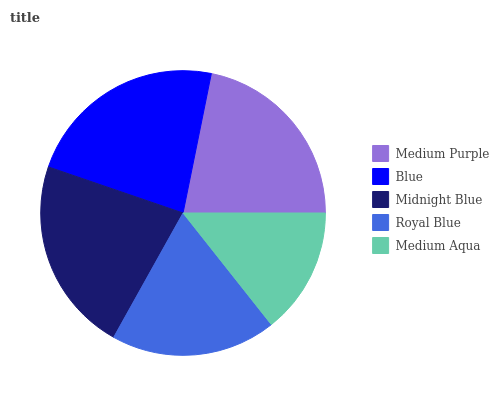Is Medium Aqua the minimum?
Answer yes or no. Yes. Is Blue the maximum?
Answer yes or no. Yes. Is Midnight Blue the minimum?
Answer yes or no. No. Is Midnight Blue the maximum?
Answer yes or no. No. Is Blue greater than Midnight Blue?
Answer yes or no. Yes. Is Midnight Blue less than Blue?
Answer yes or no. Yes. Is Midnight Blue greater than Blue?
Answer yes or no. No. Is Blue less than Midnight Blue?
Answer yes or no. No. Is Medium Purple the high median?
Answer yes or no. Yes. Is Medium Purple the low median?
Answer yes or no. Yes. Is Blue the high median?
Answer yes or no. No. Is Midnight Blue the low median?
Answer yes or no. No. 